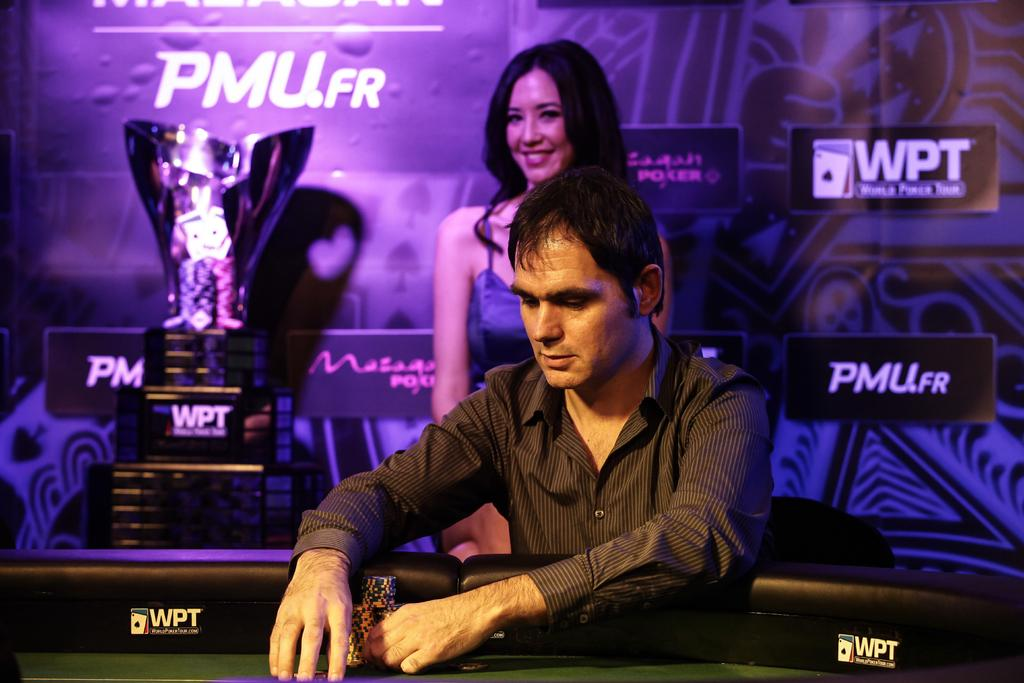<image>
Write a terse but informative summary of the picture. Person fixing something behind a booth that says WPT. 